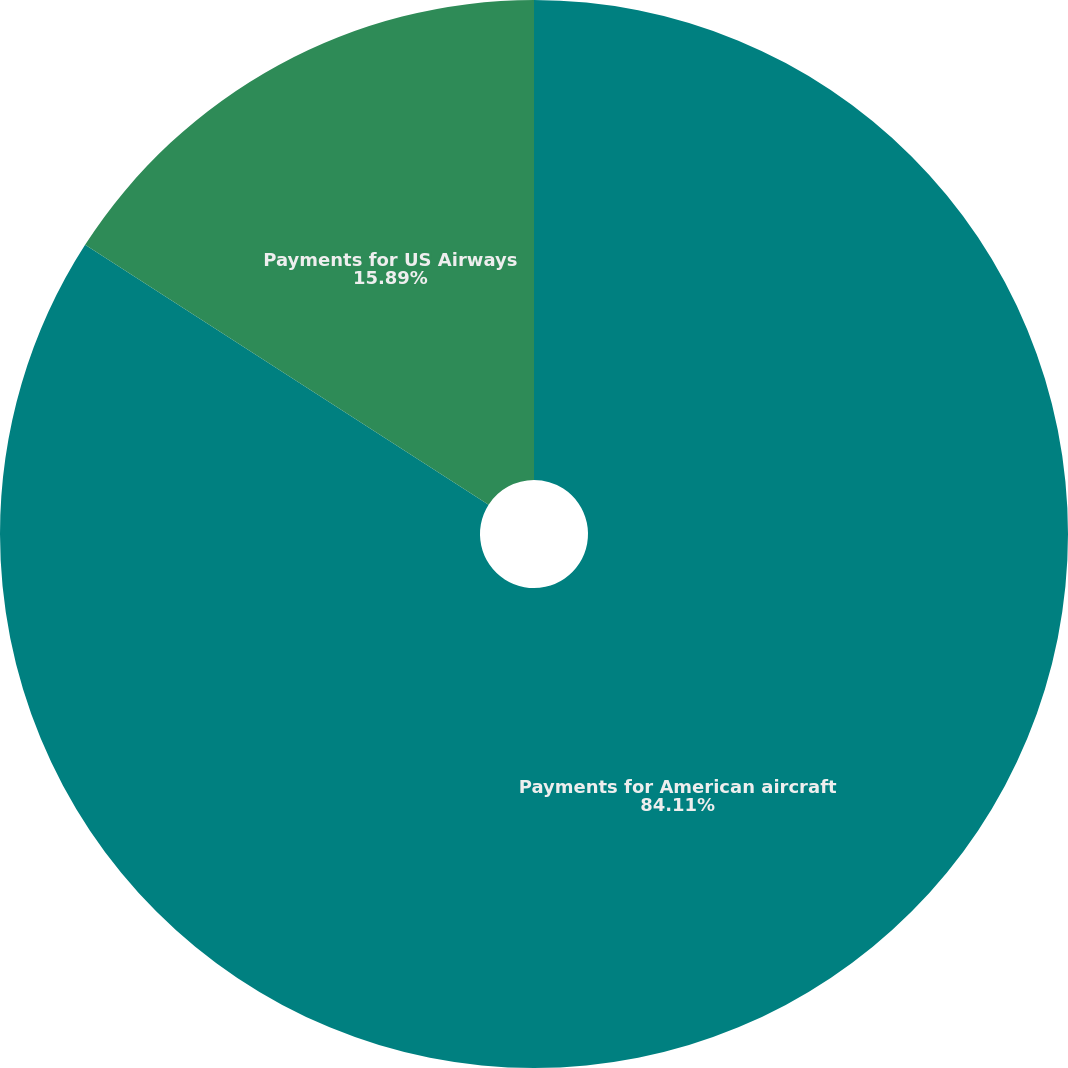Convert chart. <chart><loc_0><loc_0><loc_500><loc_500><pie_chart><fcel>Payments for American aircraft<fcel>Payments for US Airways<nl><fcel>84.11%<fcel>15.89%<nl></chart> 